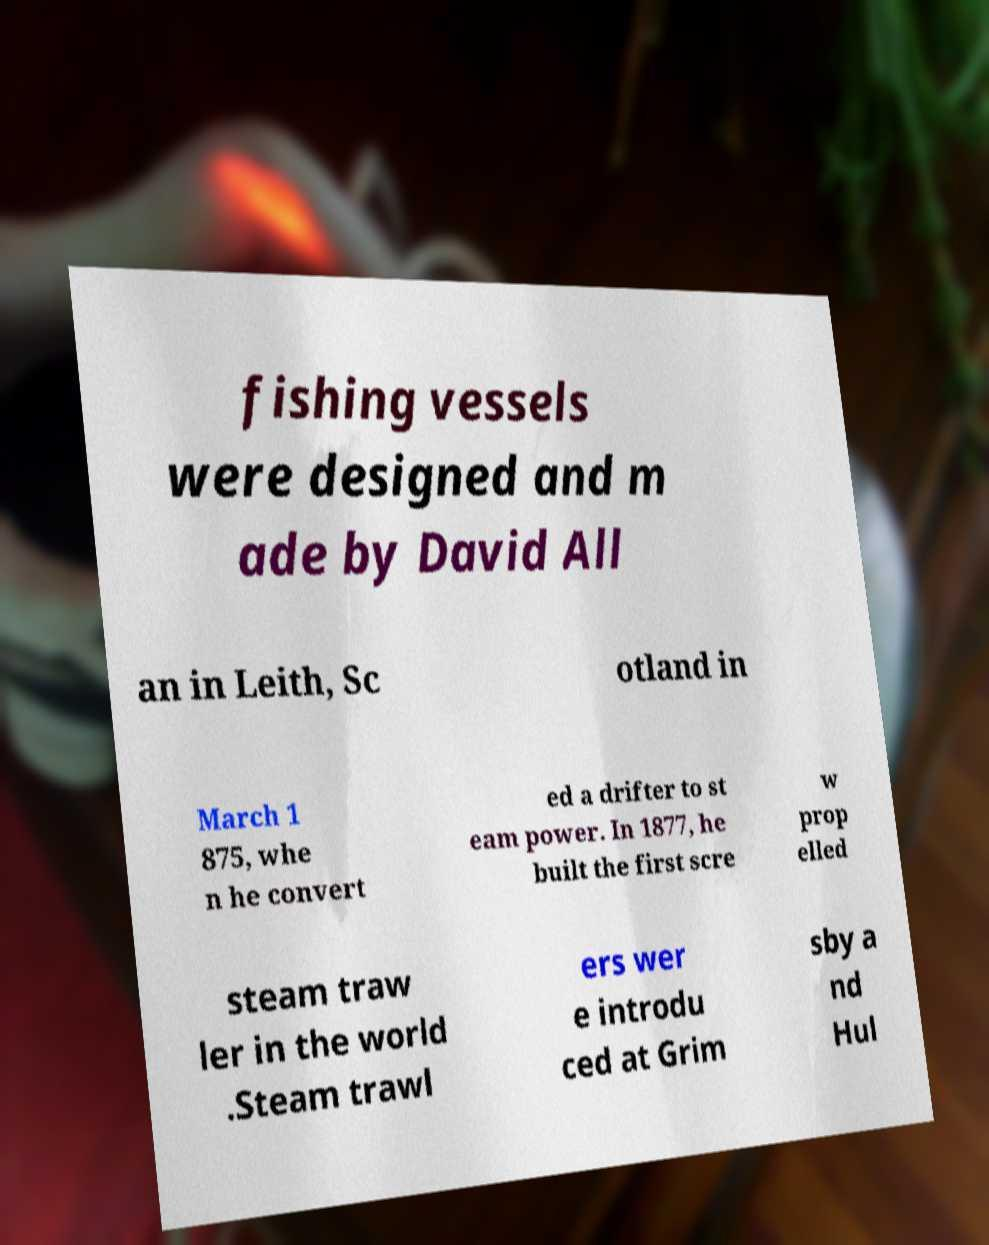For documentation purposes, I need the text within this image transcribed. Could you provide that? fishing vessels were designed and m ade by David All an in Leith, Sc otland in March 1 875, whe n he convert ed a drifter to st eam power. In 1877, he built the first scre w prop elled steam traw ler in the world .Steam trawl ers wer e introdu ced at Grim sby a nd Hul 